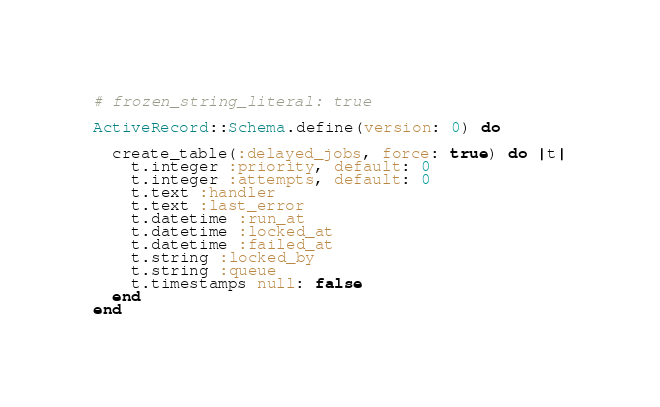Convert code to text. <code><loc_0><loc_0><loc_500><loc_500><_Ruby_># frozen_string_literal: true

ActiveRecord::Schema.define(version: 0) do

  create_table(:delayed_jobs, force: true) do |t|
    t.integer :priority, default: 0
    t.integer :attempts, default: 0
    t.text :handler
    t.text :last_error
    t.datetime :run_at
    t.datetime :locked_at
    t.datetime :failed_at
    t.string :locked_by
    t.string :queue
    t.timestamps null: false
  end
end
</code> 